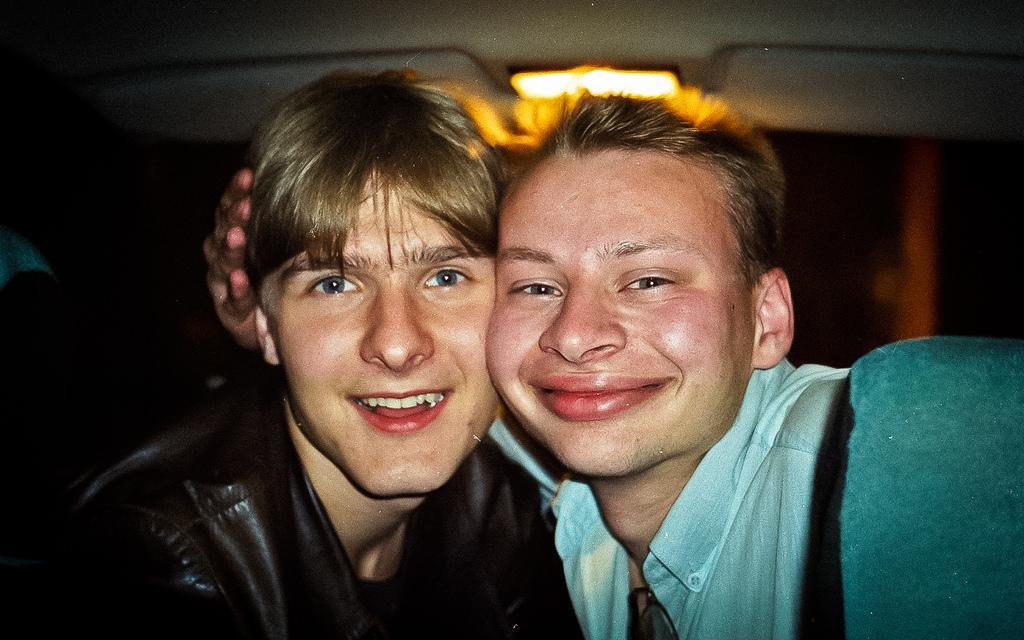How many people are in the image? There are two persons in the image. What is the lighting condition in the image? There is light at the top of the image. What is the emotional expression of the persons in the image? Both persons are smiling. What colors are the shirts of the two persons? One person is wearing a blue shirt, and the other person is wearing a black shirt. What type of instrument is the mom playing in the image? There is no mom or instrument present in the image. How many centimeters is the cent visible in the image? There is no cent present in the image. 